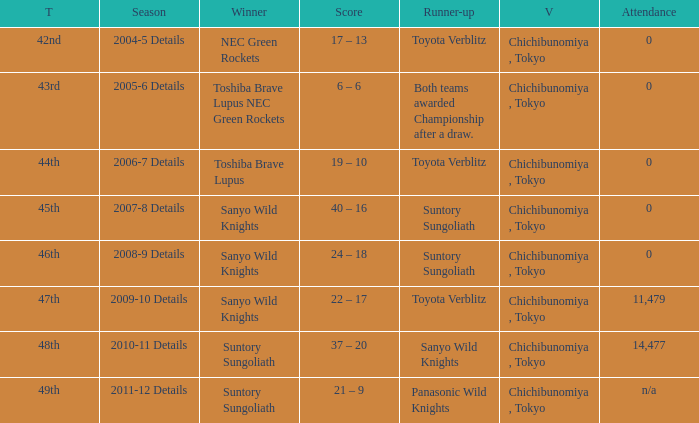What is the Attendance number for the title of 44th? 0.0. 